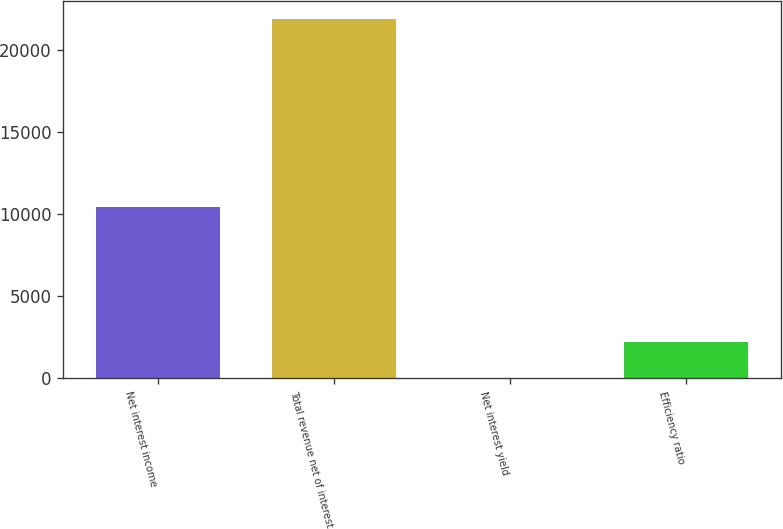Convert chart. <chart><loc_0><loc_0><loc_500><loc_500><bar_chart><fcel>Net interest income<fcel>Total revenue net of interest<fcel>Net interest yield<fcel>Efficiency ratio<nl><fcel>10429<fcel>21863<fcel>2.23<fcel>2188.31<nl></chart> 